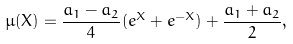<formula> <loc_0><loc_0><loc_500><loc_500>\mu ( X ) = \frac { a _ { 1 } - a _ { 2 } } { 4 } ( e ^ { X } + e ^ { - X } ) + \frac { a _ { 1 } + a _ { 2 } } { 2 } ,</formula> 